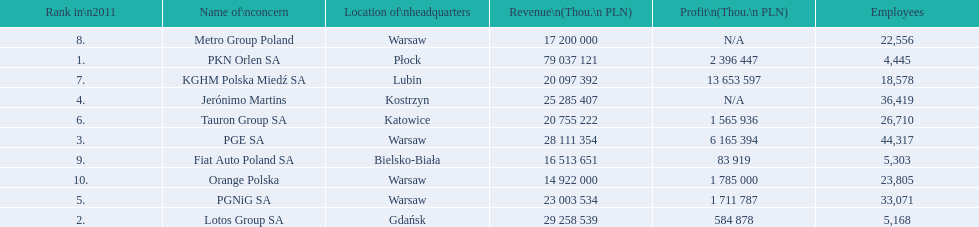What are the names of the major companies of poland? PKN Orlen SA, Lotos Group SA, PGE SA, Jerónimo Martins, PGNiG SA, Tauron Group SA, KGHM Polska Miedź SA, Metro Group Poland, Fiat Auto Poland SA, Orange Polska. What are the revenues of those companies in thou. pln? PKN Orlen SA, 79 037 121, Lotos Group SA, 29 258 539, PGE SA, 28 111 354, Jerónimo Martins, 25 285 407, PGNiG SA, 23 003 534, Tauron Group SA, 20 755 222, KGHM Polska Miedź SA, 20 097 392, Metro Group Poland, 17 200 000, Fiat Auto Poland SA, 16 513 651, Orange Polska, 14 922 000. Which of these revenues is greater than 75 000 000 thou. pln? 79 037 121. Which company has a revenue equal to 79 037 121 thou pln? PKN Orlen SA. 